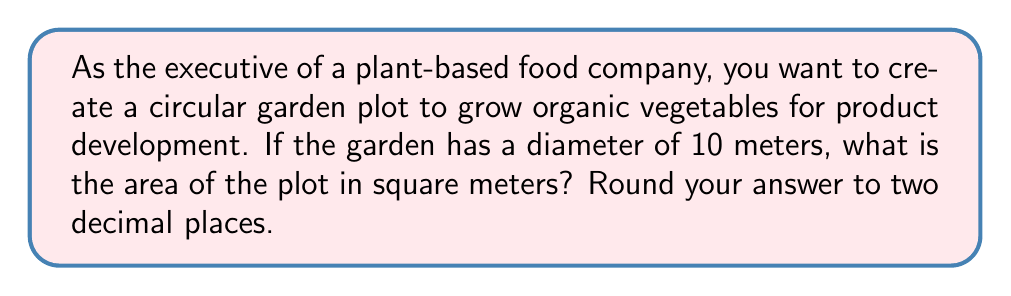Teach me how to tackle this problem. To solve this problem, we need to follow these steps:

1. Recall the formula for the area of a circle:
   $$A = \pi r^2$$
   where $A$ is the area and $r$ is the radius.

2. We are given the diameter, which is 10 meters. The radius is half of the diameter:
   $$r = \frac{diameter}{2} = \frac{10}{2} = 5\text{ meters}$$

3. Now we can substitute this value into our area formula:
   $$A = \pi (5)^2 = 25\pi\text{ square meters}$$

4. Using $\pi \approx 3.14159$, we can calculate:
   $$A \approx 25 \times 3.14159 = 78.53975\text{ square meters}$$

5. Rounding to two decimal places:
   $$A \approx 78.54\text{ square meters}$$

[asy]
unitsize(10mm);
draw(circle((0,0),5));
draw((-5,0)--(5,0),dashed);
label("10 m", (0,-5.5), S);
label("5 m", (2.5,0.3), N);
dot((0,0));
[/asy]
Answer: $78.54\text{ m}^2$ 